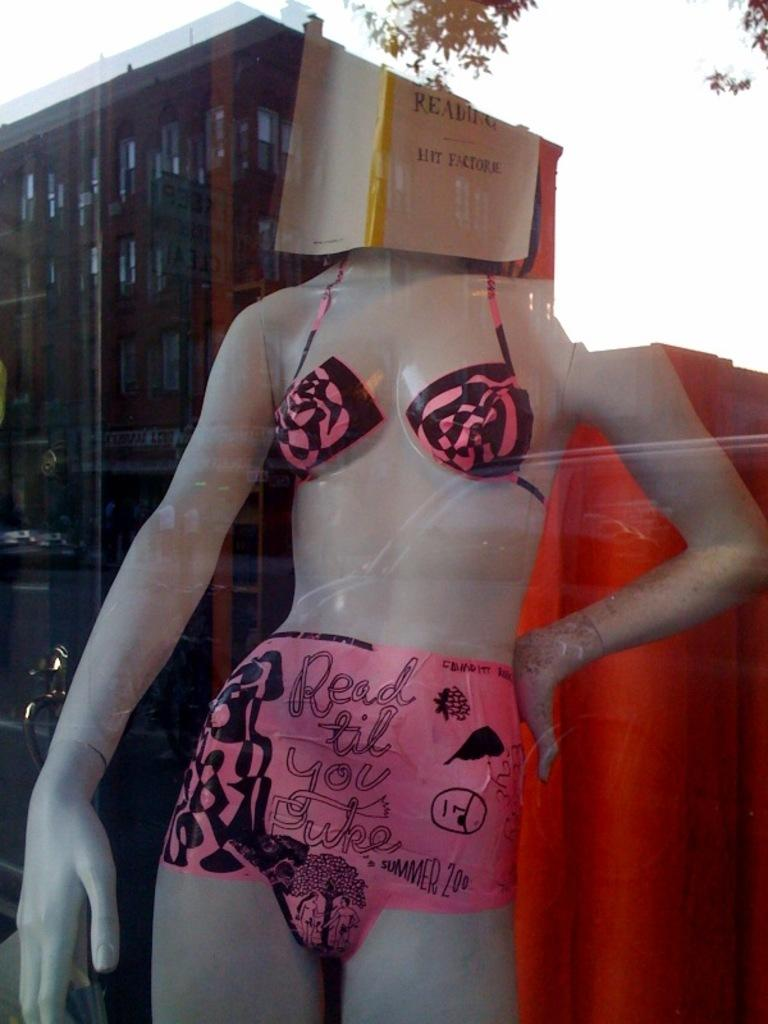What object is present in the image that is not a mannequin or a book? There is a cloth in the image. What is the mannequin doing in the image? The mannequin is holding a book in the image. What can be seen in the reflection of the image? There is a reflection of a building, leaves, and the sky in the image. What type of muscle is being exercised by the mannequin in the image? The mannequin is not a living being and therefore cannot exercise muscles. 